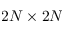Convert formula to latex. <formula><loc_0><loc_0><loc_500><loc_500>2 N \times 2 N</formula> 